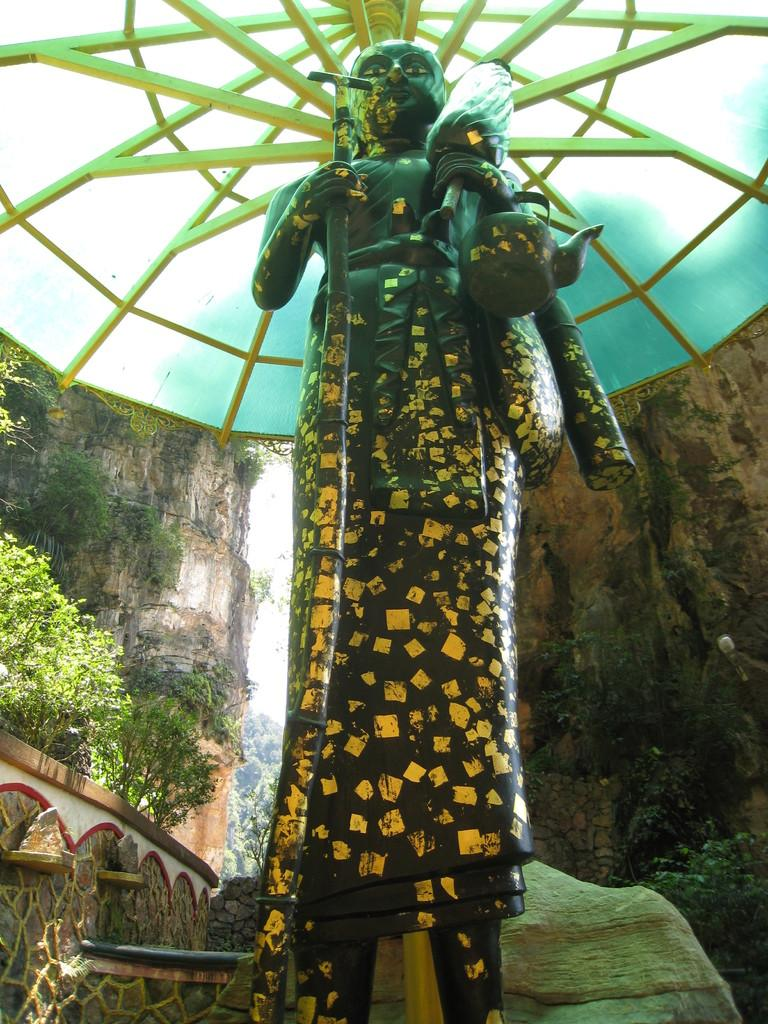What is the main subject of the image? There is a statue of a person in the image. What is the statue holding? The statue is holding an item that resembles an umbrella. What type of natural features can be seen in the image? There are rocks, trees, and hills visible in the image. What is visible in the background of the image? The sky is visible in the image. How many eggs are being carried by the person in the image? There is no person carrying eggs in the image; it features a statue holding an item that resembles an umbrella. What is the altitude of the location in the image? The altitude cannot be determined from the image, as it only shows a statue, rocks, trees, hills, and the sky. 